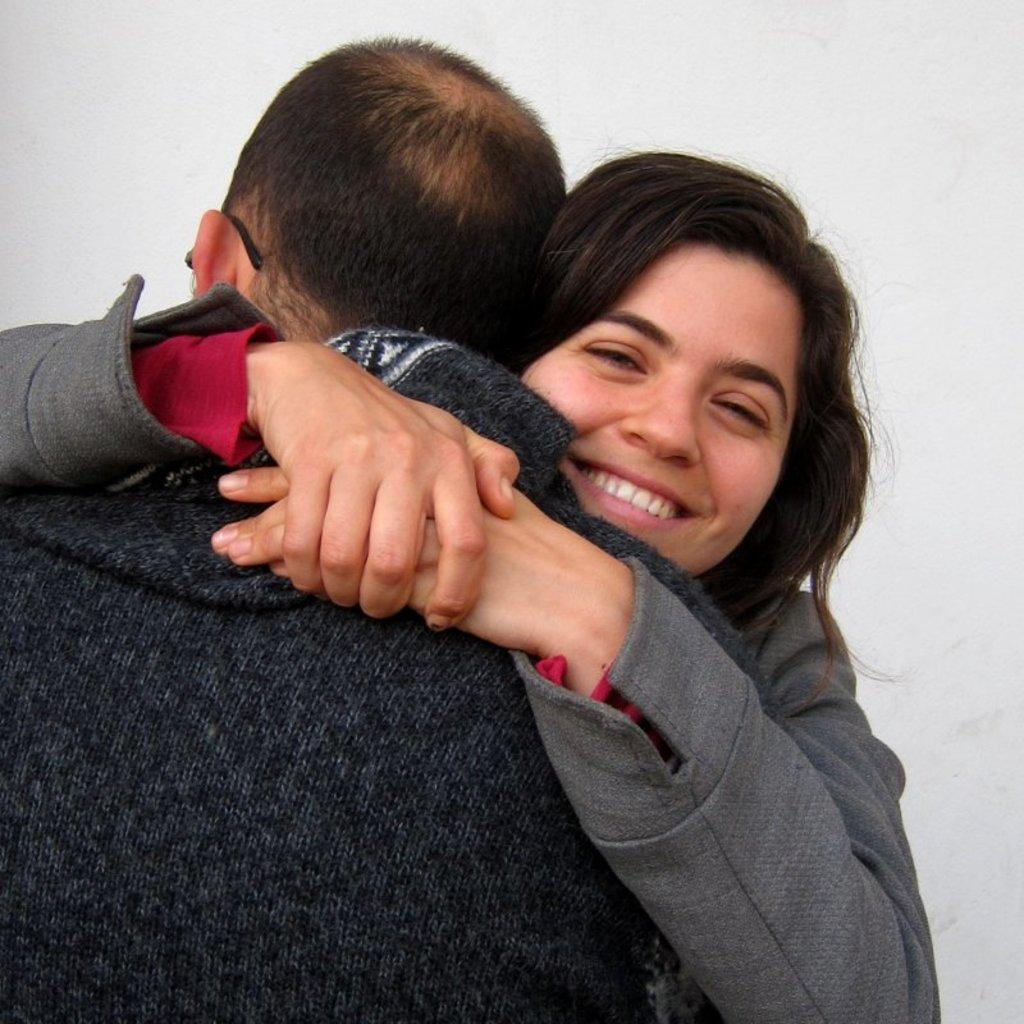How many people are in the image? There are two people in the image. What are the two people doing? The two people are holding each other. Can you describe the facial expression of one of the people? One of the people is smiling. What color is the background of the image? The background of the image is white. Where can the lizards be seen in the image? A: There are no lizards present in the image. What type of transportation can be seen at the airport in the image? There is no airport present in the image. 